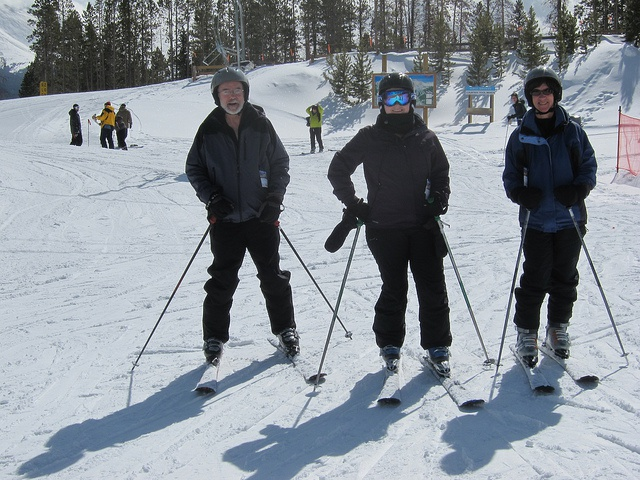Describe the objects in this image and their specific colors. I can see people in lightgray, black, and gray tones, people in lightgray, black, gray, and darkgray tones, people in lightgray, black, gray, and navy tones, skis in lightgray, gray, and black tones, and skis in lightgray, darkgray, and black tones in this image. 